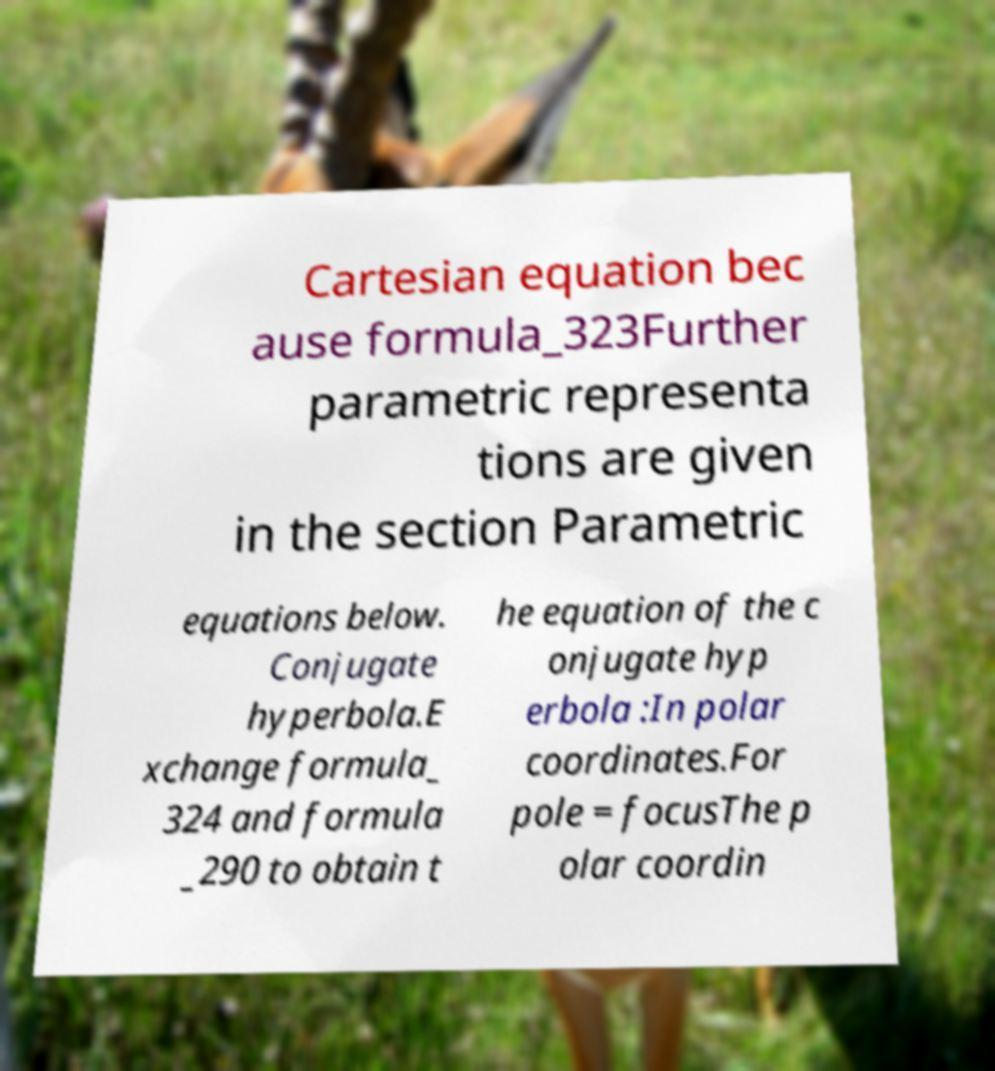Could you extract and type out the text from this image? Cartesian equation bec ause formula_323Further parametric representa tions are given in the section Parametric equations below. Conjugate hyperbola.E xchange formula_ 324 and formula _290 to obtain t he equation of the c onjugate hyp erbola :In polar coordinates.For pole = focusThe p olar coordin 